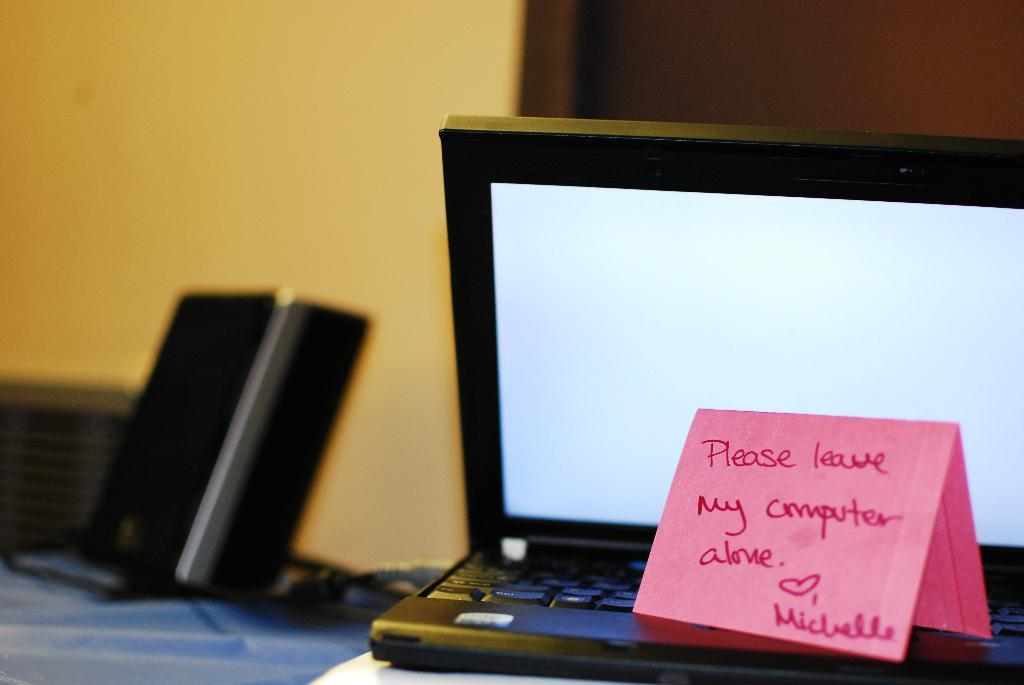<image>
Relay a brief, clear account of the picture shown. Someone has put a pink post-it note on a computer that says "please leave my computer alone". 